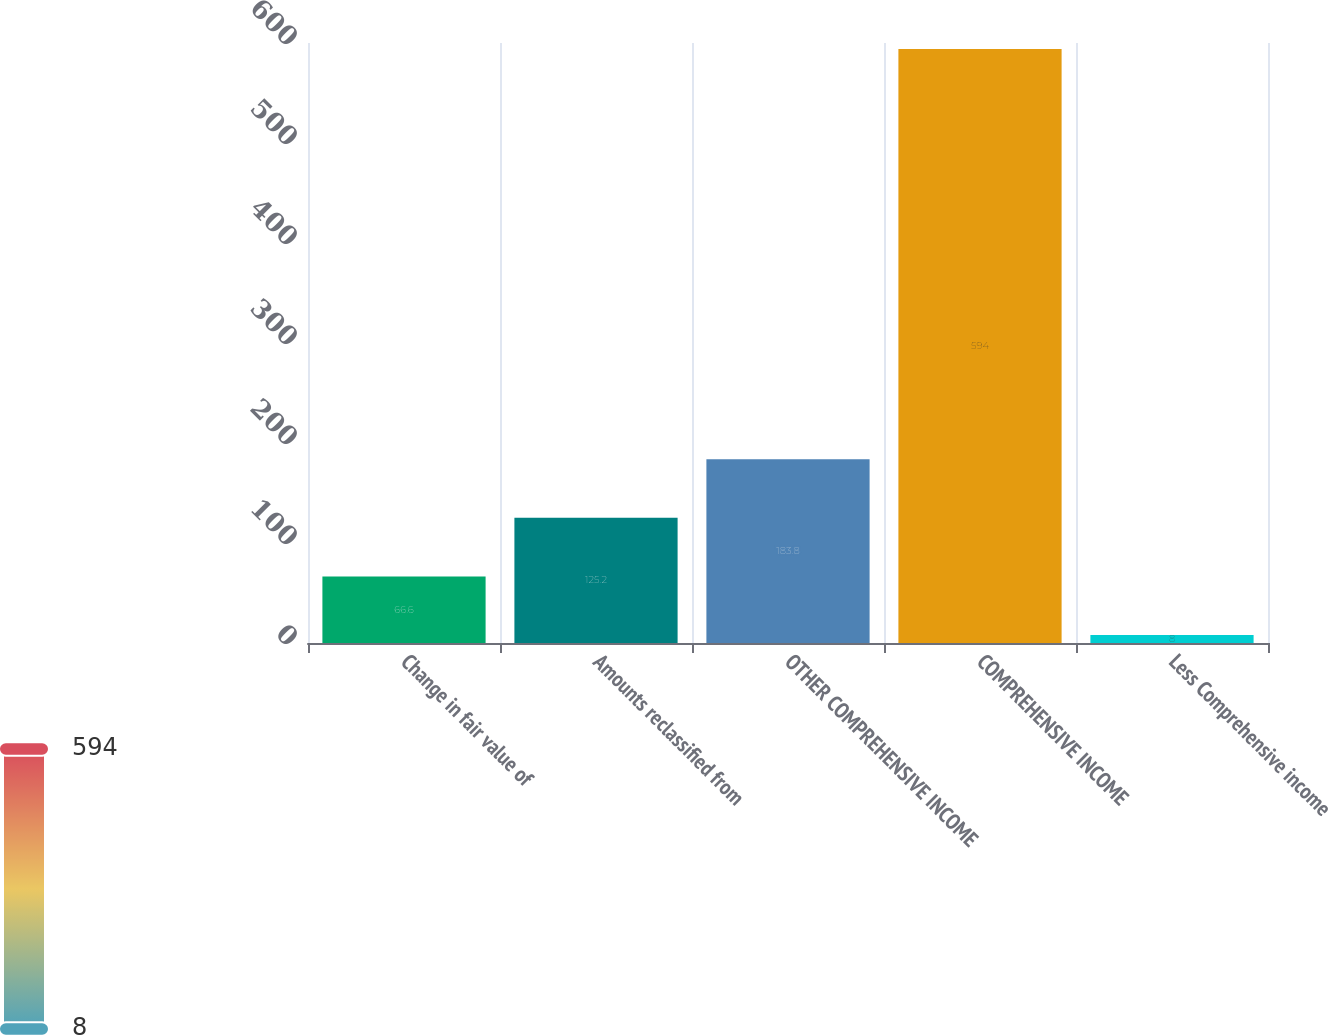<chart> <loc_0><loc_0><loc_500><loc_500><bar_chart><fcel>Change in fair value of<fcel>Amounts reclassified from<fcel>OTHER COMPREHENSIVE INCOME<fcel>COMPREHENSIVE INCOME<fcel>Less Comprehensive income<nl><fcel>66.6<fcel>125.2<fcel>183.8<fcel>594<fcel>8<nl></chart> 